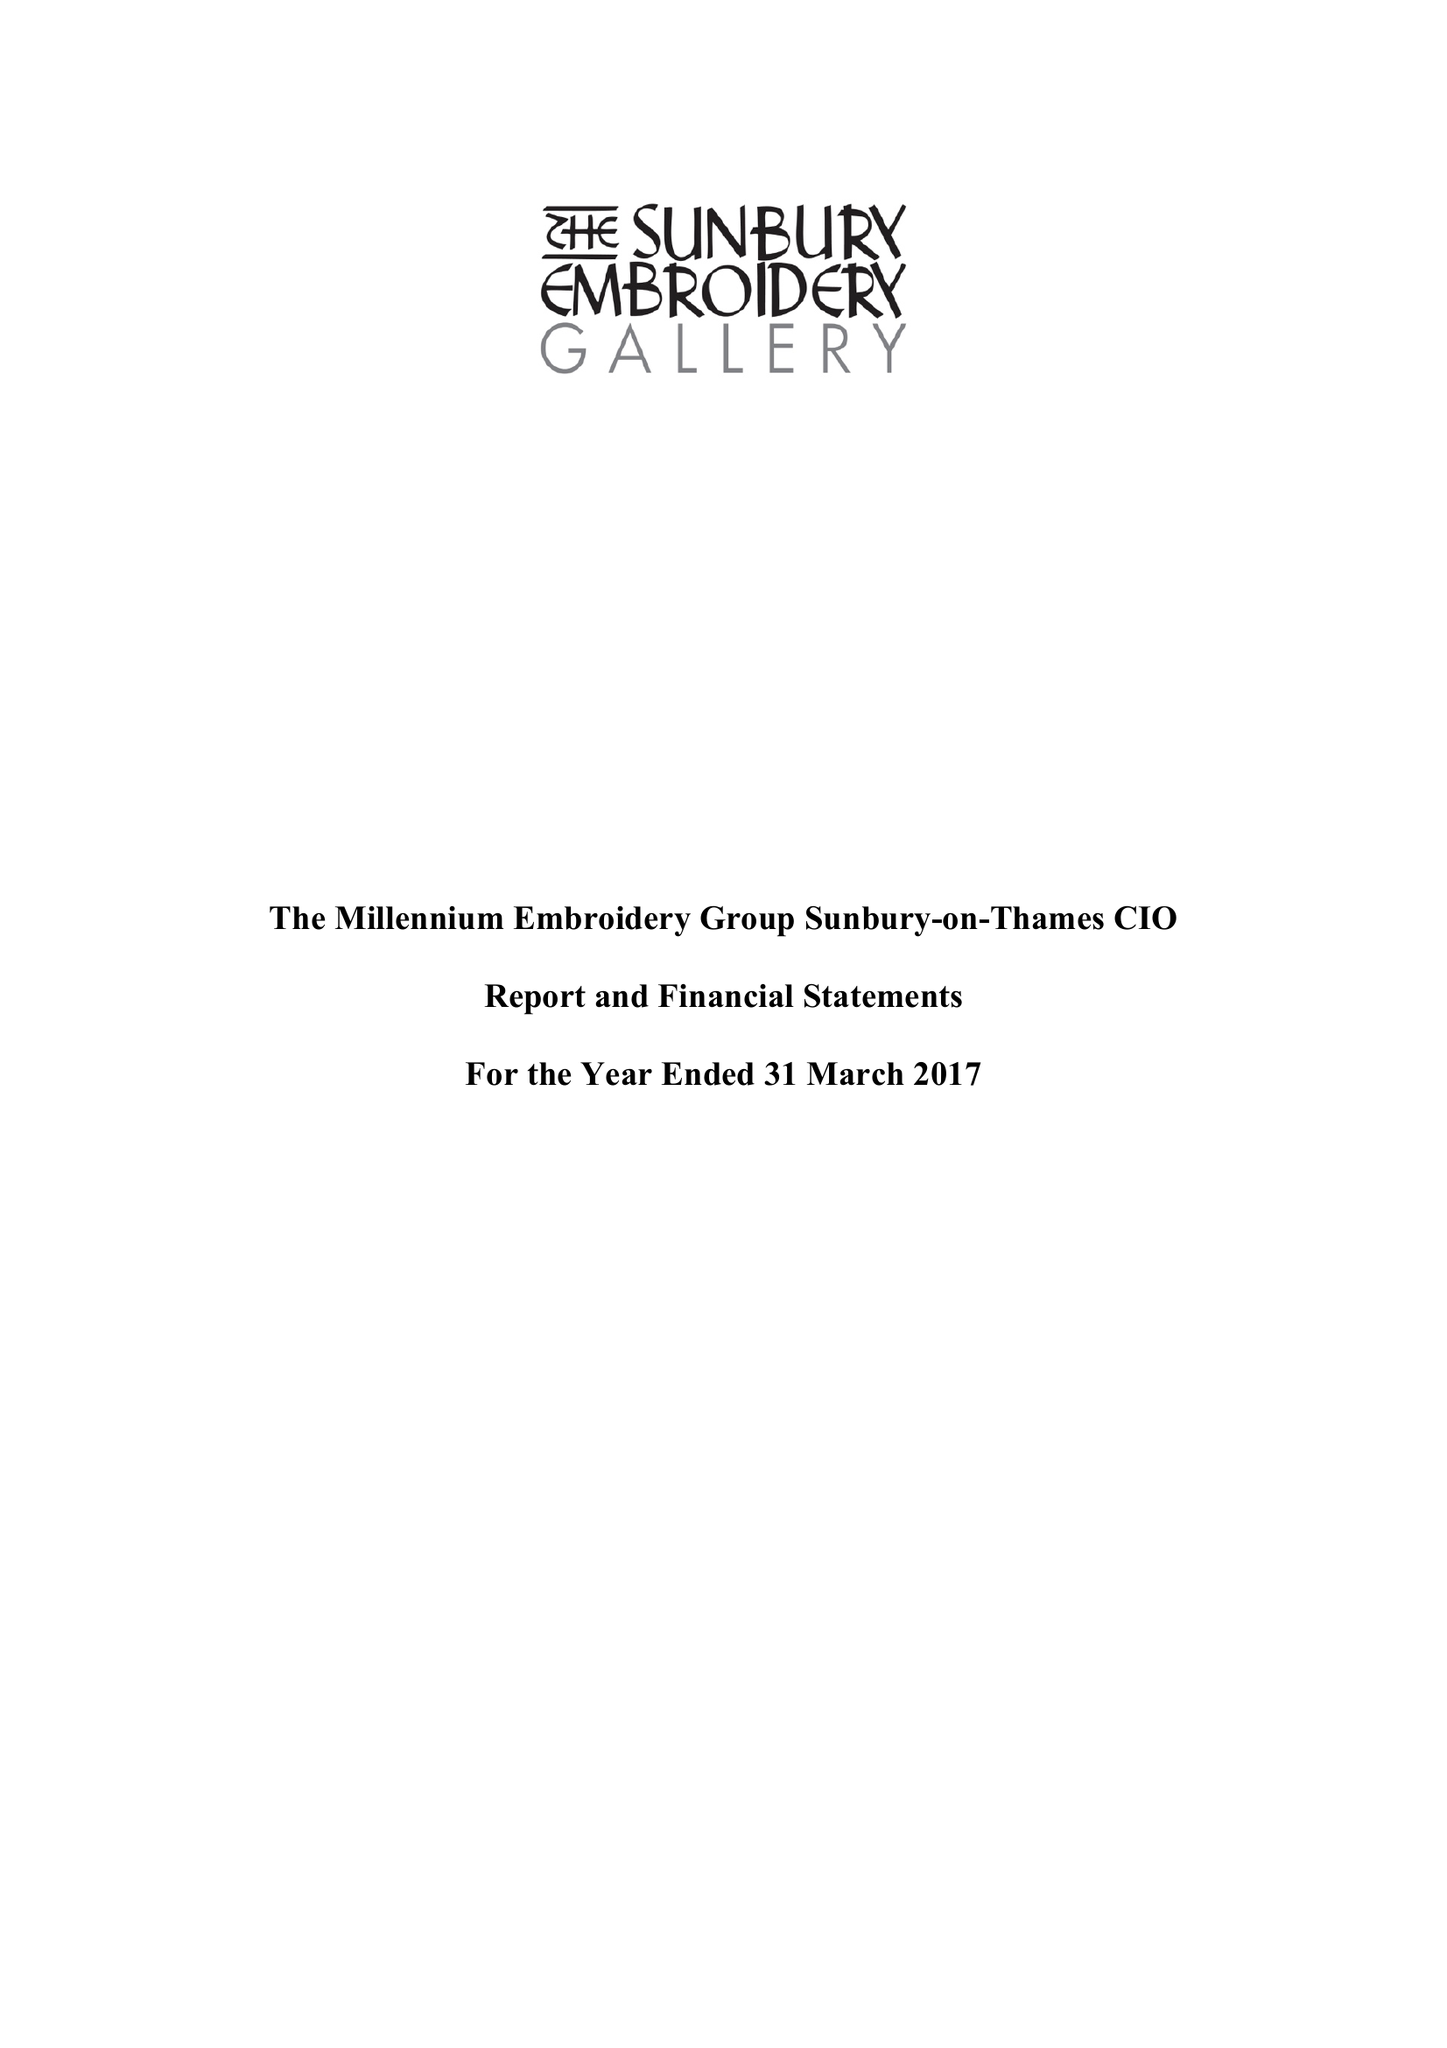What is the value for the address__street_line?
Answer the question using a single word or phrase. THAMES STREET 